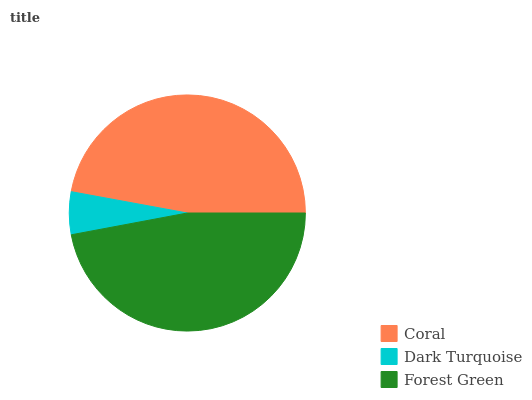Is Dark Turquoise the minimum?
Answer yes or no. Yes. Is Coral the maximum?
Answer yes or no. Yes. Is Forest Green the minimum?
Answer yes or no. No. Is Forest Green the maximum?
Answer yes or no. No. Is Forest Green greater than Dark Turquoise?
Answer yes or no. Yes. Is Dark Turquoise less than Forest Green?
Answer yes or no. Yes. Is Dark Turquoise greater than Forest Green?
Answer yes or no. No. Is Forest Green less than Dark Turquoise?
Answer yes or no. No. Is Forest Green the high median?
Answer yes or no. Yes. Is Forest Green the low median?
Answer yes or no. Yes. Is Coral the high median?
Answer yes or no. No. Is Coral the low median?
Answer yes or no. No. 